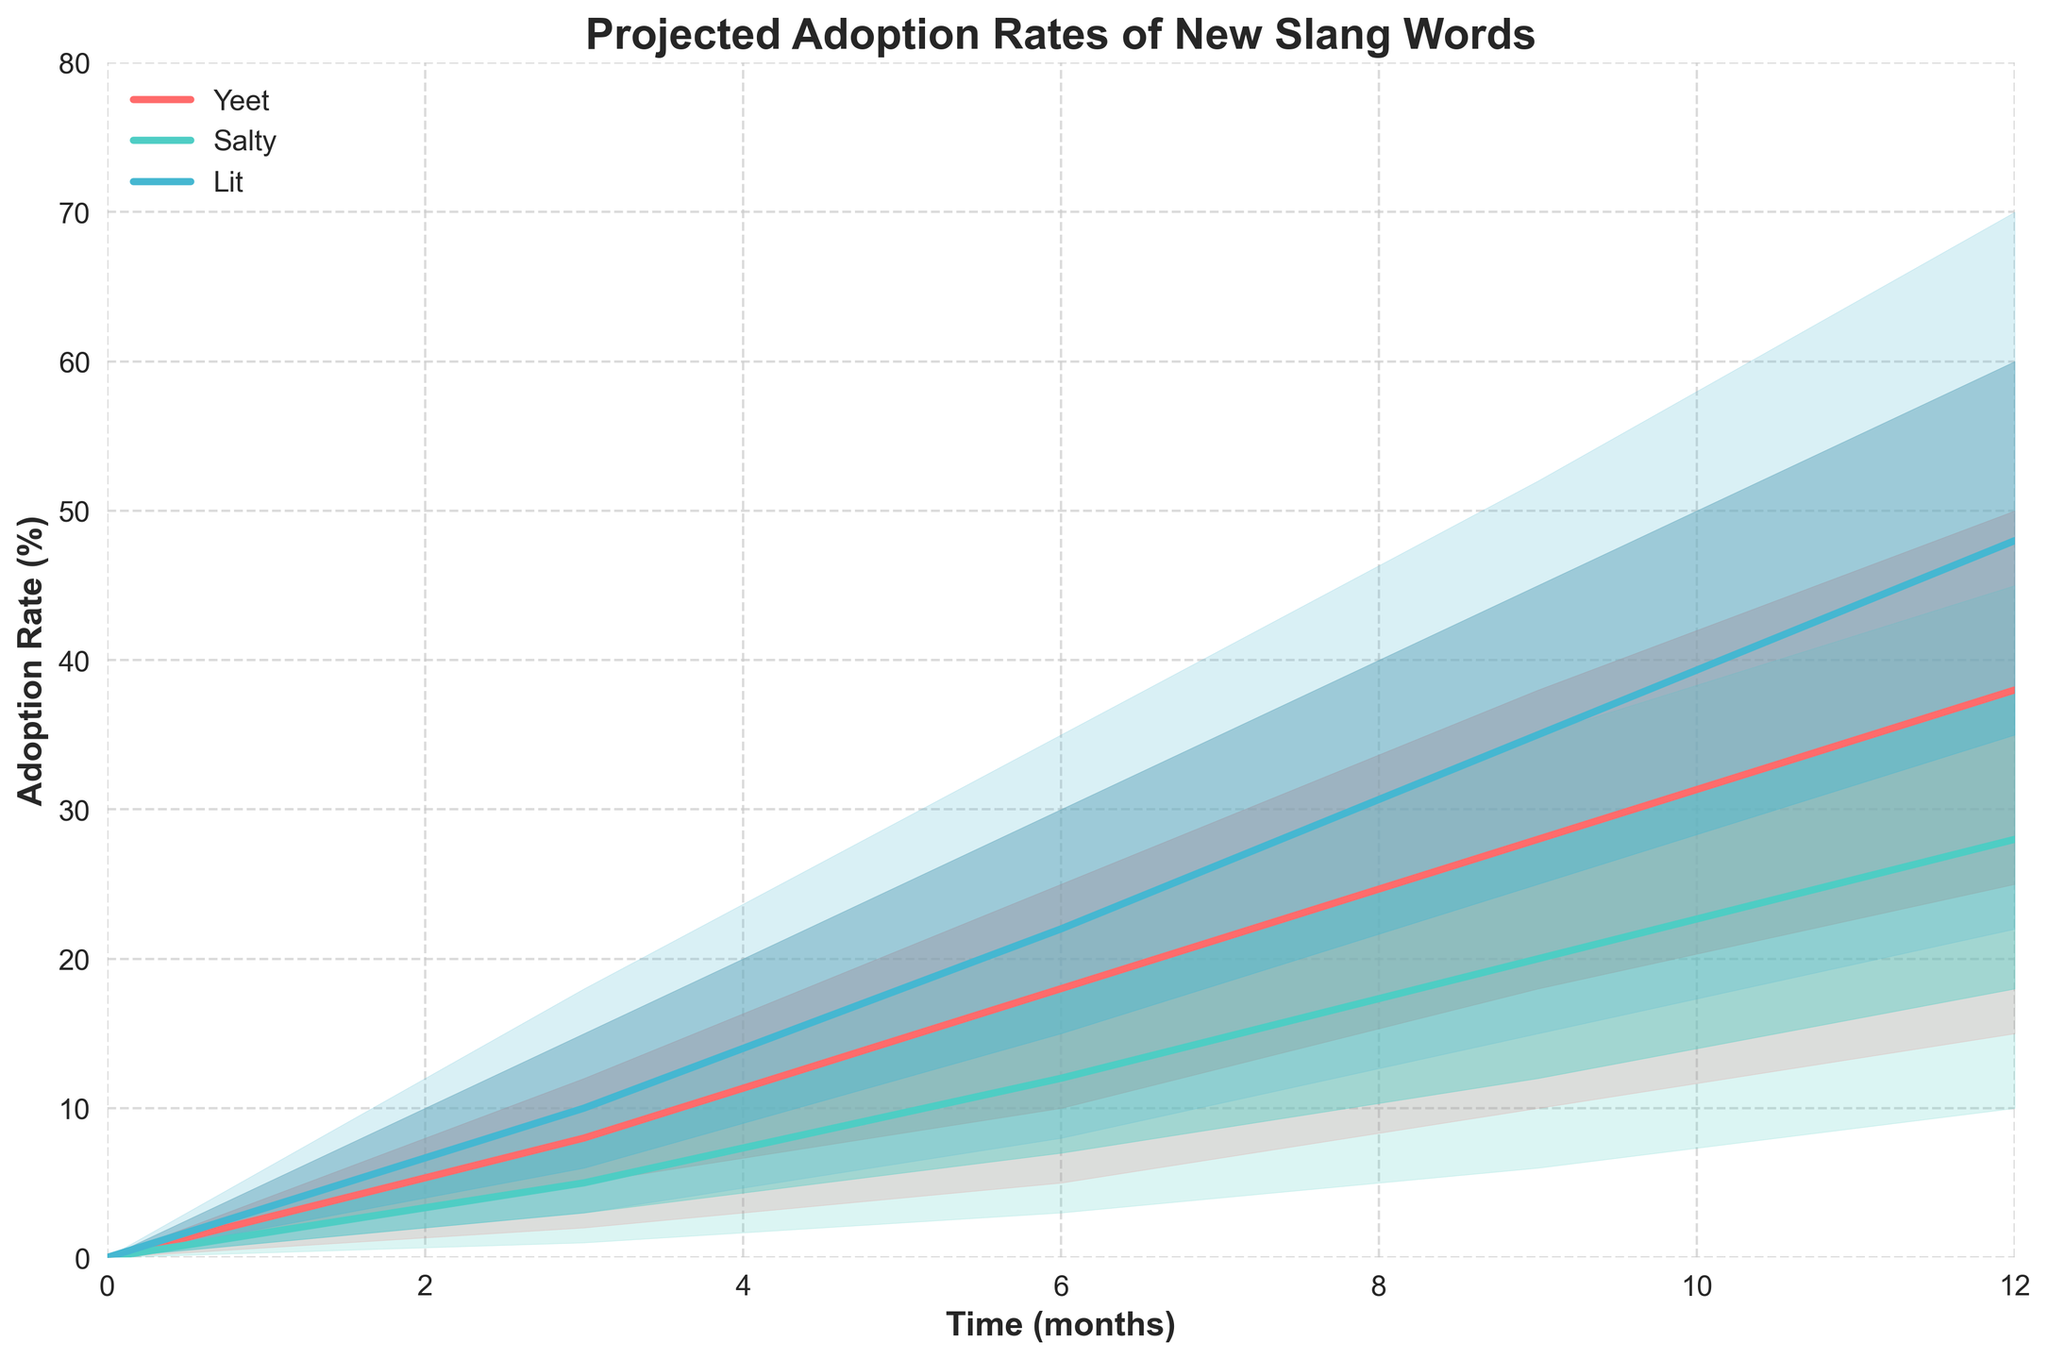What is the title of the figure? The title is typically displayed at the top of a chart to indicate what the chart is about. In this case, the title is "Projected Adoption Rates of New Slang Words".
Answer: Projected Adoption Rates of New Slang Words What are the colors used to represent the different slang words? The colors distinguish different slang words in the chart. Yeet is represented in a reddish color, Salty in a teal color, and Lit in a blue color.
Answer: Reddish, teal, blue How many slang words are compared in the chart? The chart compares the projected adoption rates of three different slang words over time. The legend shows three entries: Yeet, Salty, and Lit.
Answer: 3 Which slang word has the highest median adoption rate at 12 months? To find this, look for the highest median value at the 12-month mark on the x-axis. Lit has the highest median value at 48%.
Answer: Lit At 6 months, which slang word has the widest confidence interval? Compare the ranges between the High90 and Low90 values at the 6-month point for each word. Lit has the widest range (35 - 8 = 27%).
Answer: Lit What is the median adoption rate of 'Salty' at 9 months? Check the median value for 'Salty' at the 9-month mark on the chart. It is 20%.
Answer: 20% Which slang word shows the fastest adoption rate increase between 0 and 6 months? Calculate the difference in the median adoption rate between 0 and 6 months for each word. Lit increases from 0% to 22%, which is the highest increase (22%).
Answer: Lit What is the median adoption rate of 'Yeet' at 3 months, and how much does it increase by 12 months? Find the median value at 3 months and at 12 months for 'Yeet', then calculate the difference. The median at 3 months is 8%, and at 12 months, it is 38%. The increase is 30%.
Answer: 30% Which slang word has a median adoption rate of 28% at 9 months? Locate the median value of 28% at 9 months, which corresponds to 'Yeet'.
Answer: Yeet By how much does the lower bound of Salty's 75% confidence interval increase from 3 months to 12 months? Find the Low75 value for 'Salty' at 3 months (3%) and 12 months (18%). The increase is 15%.
Answer: 15% 